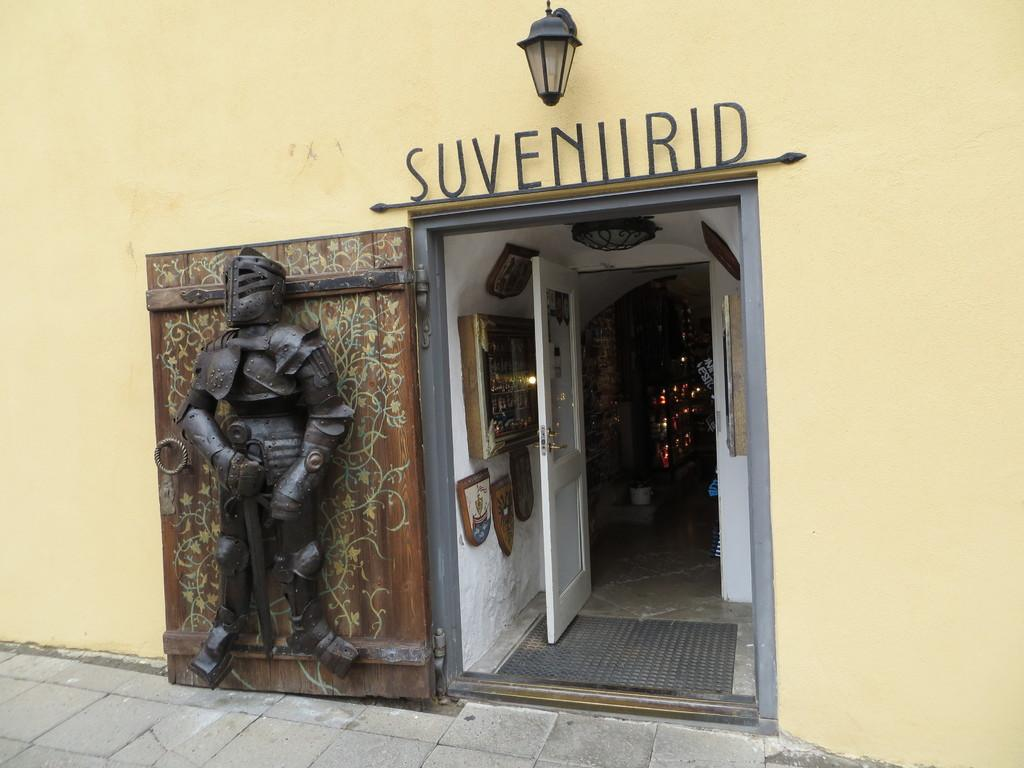What is located on the left side of the image? There is an iron statue on the left side of the image. What is the iron statue attached to? The iron statue is attached to a door. What can be seen in the middle of the image? There is an entrance in the middle of the image. What is depicted on a wall at the top of the image? There is a lamb depicted on a wall at the top of the image. What language is spoken by the lamb in the image? The image does not depict a speaking lamb, and therefore it is not possible to determine the language spoken by the lamb. Is there a veil covering the entrance in the image? There is no mention of a veil in the provided facts, and therefore it cannot be determined if there is a veil covering the entrance in the image. 